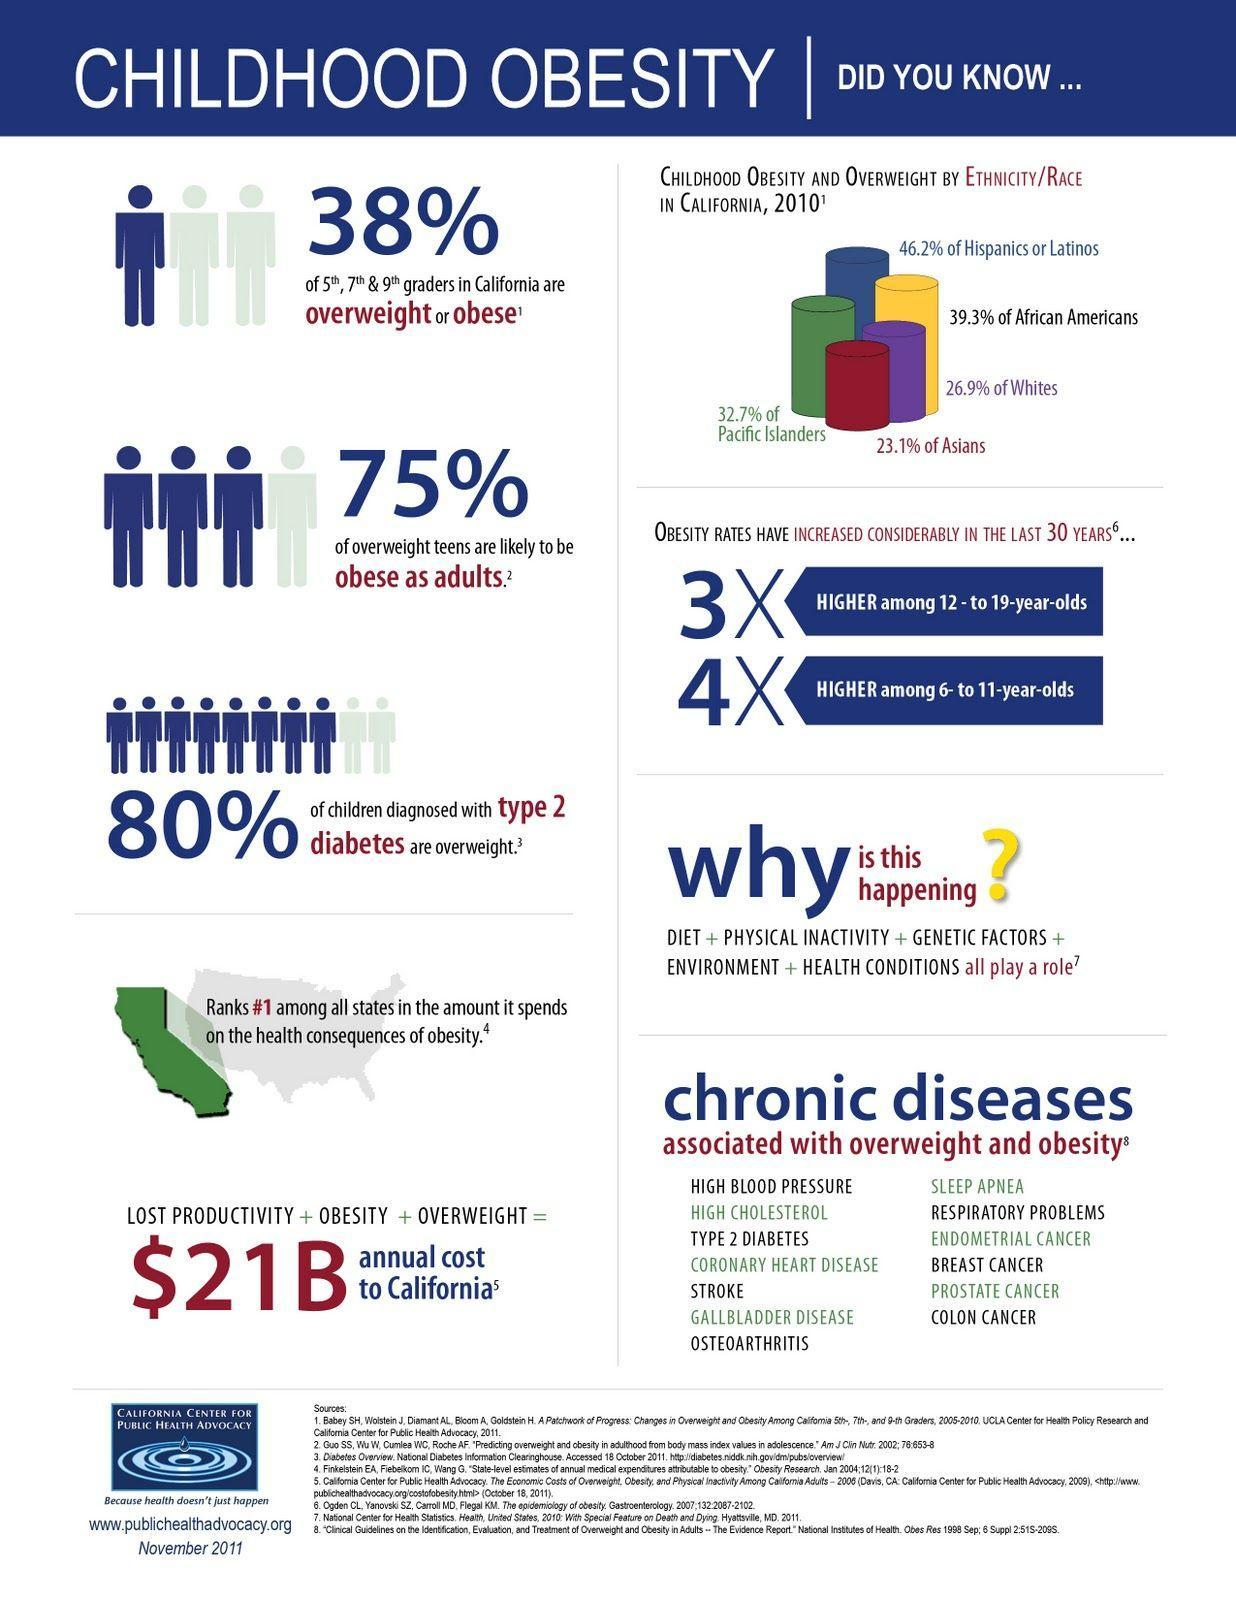How many factors play a role in childhood obesity?
Answer the question with a short phrase. 5 What is the difference in percentages of Hispanics and African Americans? 6.9% Which color represents the percentage weight of Asians, green, yellow, or red ? red Which state ranks first in obesity? California How many diseases are related overweight and obesity? 13 Which ethinicity or race has the second lowest percentage of obesity Asians, Whites, or Pacific Islanders? Whites 